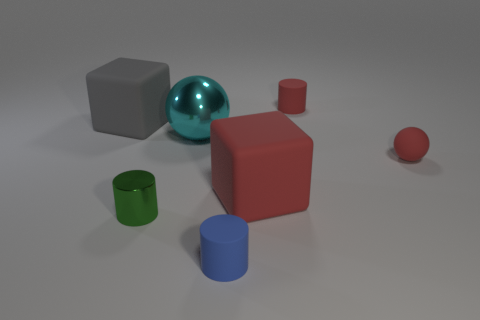Subtract all small rubber cylinders. How many cylinders are left? 1 Add 2 cyan things. How many objects exist? 9 Subtract 1 cylinders. How many cylinders are left? 2 Subtract all balls. How many objects are left? 5 Add 1 big gray things. How many big gray things exist? 2 Subtract 0 green blocks. How many objects are left? 7 Subtract all purple cylinders. Subtract all gray cubes. How many cylinders are left? 3 Subtract all big gray blocks. Subtract all tiny rubber spheres. How many objects are left? 5 Add 5 small green cylinders. How many small green cylinders are left? 6 